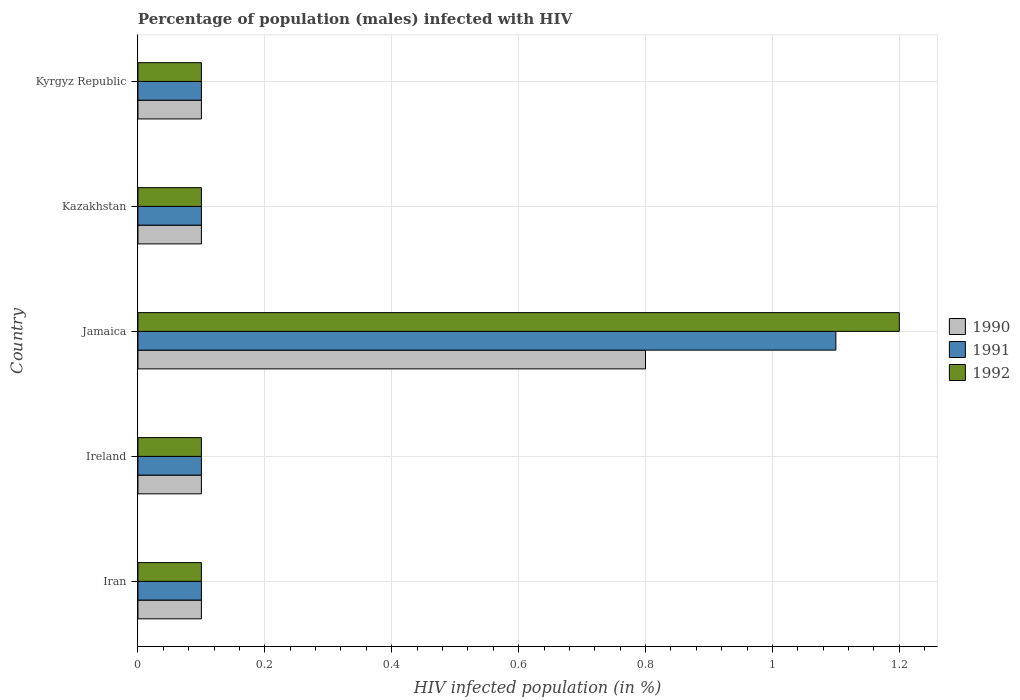How many groups of bars are there?
Your answer should be compact. 5. Are the number of bars per tick equal to the number of legend labels?
Keep it short and to the point. Yes. How many bars are there on the 5th tick from the top?
Offer a very short reply. 3. What is the label of the 4th group of bars from the top?
Offer a terse response. Ireland. What is the percentage of HIV infected male population in 1991 in Jamaica?
Provide a short and direct response. 1.1. Across all countries, what is the minimum percentage of HIV infected male population in 1992?
Offer a very short reply. 0.1. In which country was the percentage of HIV infected male population in 1990 maximum?
Your response must be concise. Jamaica. In which country was the percentage of HIV infected male population in 1992 minimum?
Give a very brief answer. Iran. What is the total percentage of HIV infected male population in 1990 in the graph?
Provide a succinct answer. 1.2. What is the difference between the percentage of HIV infected male population in 1992 in Iran and that in Jamaica?
Your answer should be compact. -1.1. What is the average percentage of HIV infected male population in 1990 per country?
Your answer should be very brief. 0.24. In how many countries, is the percentage of HIV infected male population in 1991 greater than 0.6400000000000001 %?
Offer a terse response. 1. What is the ratio of the percentage of HIV infected male population in 1990 in Jamaica to that in Kazakhstan?
Make the answer very short. 8. Is the percentage of HIV infected male population in 1991 in Jamaica less than that in Kyrgyz Republic?
Provide a short and direct response. No. What is the difference between the highest and the second highest percentage of HIV infected male population in 1990?
Your answer should be compact. 0.7. What is the difference between the highest and the lowest percentage of HIV infected male population in 1992?
Ensure brevity in your answer.  1.1. In how many countries, is the percentage of HIV infected male population in 1991 greater than the average percentage of HIV infected male population in 1991 taken over all countries?
Offer a very short reply. 1. Is the sum of the percentage of HIV infected male population in 1992 in Ireland and Kyrgyz Republic greater than the maximum percentage of HIV infected male population in 1991 across all countries?
Offer a very short reply. No. What does the 3rd bar from the top in Kazakhstan represents?
Provide a short and direct response. 1990. What does the 1st bar from the bottom in Kazakhstan represents?
Provide a short and direct response. 1990. How many bars are there?
Offer a terse response. 15. Does the graph contain any zero values?
Provide a succinct answer. No. Does the graph contain grids?
Make the answer very short. Yes. How many legend labels are there?
Ensure brevity in your answer.  3. How are the legend labels stacked?
Ensure brevity in your answer.  Vertical. What is the title of the graph?
Keep it short and to the point. Percentage of population (males) infected with HIV. What is the label or title of the X-axis?
Make the answer very short. HIV infected population (in %). What is the HIV infected population (in %) in 1990 in Iran?
Offer a terse response. 0.1. What is the HIV infected population (in %) in 1991 in Iran?
Give a very brief answer. 0.1. What is the HIV infected population (in %) in 1992 in Iran?
Keep it short and to the point. 0.1. What is the HIV infected population (in %) of 1991 in Ireland?
Provide a succinct answer. 0.1. What is the HIV infected population (in %) of 1992 in Ireland?
Keep it short and to the point. 0.1. What is the HIV infected population (in %) of 1990 in Jamaica?
Your answer should be compact. 0.8. What is the HIV infected population (in %) in 1991 in Jamaica?
Ensure brevity in your answer.  1.1. What is the HIV infected population (in %) in 1992 in Jamaica?
Your answer should be very brief. 1.2. What is the HIV infected population (in %) of 1990 in Kyrgyz Republic?
Your response must be concise. 0.1. What is the HIV infected population (in %) of 1991 in Kyrgyz Republic?
Give a very brief answer. 0.1. What is the HIV infected population (in %) of 1992 in Kyrgyz Republic?
Offer a terse response. 0.1. Across all countries, what is the maximum HIV infected population (in %) of 1991?
Your response must be concise. 1.1. Across all countries, what is the maximum HIV infected population (in %) in 1992?
Your answer should be very brief. 1.2. Across all countries, what is the minimum HIV infected population (in %) in 1992?
Keep it short and to the point. 0.1. What is the total HIV infected population (in %) in 1991 in the graph?
Provide a succinct answer. 1.5. What is the total HIV infected population (in %) in 1992 in the graph?
Offer a terse response. 1.6. What is the difference between the HIV infected population (in %) of 1990 in Iran and that in Ireland?
Your response must be concise. 0. What is the difference between the HIV infected population (in %) in 1991 in Iran and that in Ireland?
Keep it short and to the point. 0. What is the difference between the HIV infected population (in %) of 1992 in Iran and that in Ireland?
Your answer should be compact. 0. What is the difference between the HIV infected population (in %) in 1990 in Iran and that in Jamaica?
Your response must be concise. -0.7. What is the difference between the HIV infected population (in %) in 1991 in Iran and that in Jamaica?
Keep it short and to the point. -1. What is the difference between the HIV infected population (in %) in 1992 in Iran and that in Jamaica?
Offer a terse response. -1.1. What is the difference between the HIV infected population (in %) in 1991 in Iran and that in Kazakhstan?
Give a very brief answer. 0. What is the difference between the HIV infected population (in %) of 1992 in Iran and that in Kazakhstan?
Your response must be concise. 0. What is the difference between the HIV infected population (in %) in 1990 in Iran and that in Kyrgyz Republic?
Provide a succinct answer. 0. What is the difference between the HIV infected population (in %) in 1992 in Iran and that in Kyrgyz Republic?
Ensure brevity in your answer.  0. What is the difference between the HIV infected population (in %) of 1992 in Ireland and that in Jamaica?
Make the answer very short. -1.1. What is the difference between the HIV infected population (in %) in 1992 in Ireland and that in Kazakhstan?
Your response must be concise. 0. What is the difference between the HIV infected population (in %) of 1991 in Ireland and that in Kyrgyz Republic?
Ensure brevity in your answer.  0. What is the difference between the HIV infected population (in %) in 1991 in Jamaica and that in Kazakhstan?
Ensure brevity in your answer.  1. What is the difference between the HIV infected population (in %) in 1991 in Kazakhstan and that in Kyrgyz Republic?
Your response must be concise. 0. What is the difference between the HIV infected population (in %) of 1992 in Kazakhstan and that in Kyrgyz Republic?
Ensure brevity in your answer.  0. What is the difference between the HIV infected population (in %) of 1990 in Iran and the HIV infected population (in %) of 1992 in Ireland?
Provide a short and direct response. 0. What is the difference between the HIV infected population (in %) in 1991 in Iran and the HIV infected population (in %) in 1992 in Ireland?
Make the answer very short. 0. What is the difference between the HIV infected population (in %) in 1990 in Iran and the HIV infected population (in %) in 1992 in Jamaica?
Keep it short and to the point. -1.1. What is the difference between the HIV infected population (in %) of 1991 in Iran and the HIV infected population (in %) of 1992 in Kazakhstan?
Ensure brevity in your answer.  0. What is the difference between the HIV infected population (in %) in 1990 in Iran and the HIV infected population (in %) in 1992 in Kyrgyz Republic?
Your answer should be compact. 0. What is the difference between the HIV infected population (in %) in 1991 in Iran and the HIV infected population (in %) in 1992 in Kyrgyz Republic?
Your response must be concise. 0. What is the difference between the HIV infected population (in %) of 1990 in Ireland and the HIV infected population (in %) of 1991 in Jamaica?
Your answer should be very brief. -1. What is the difference between the HIV infected population (in %) in 1990 in Ireland and the HIV infected population (in %) in 1991 in Kyrgyz Republic?
Provide a succinct answer. 0. What is the difference between the HIV infected population (in %) in 1991 in Ireland and the HIV infected population (in %) in 1992 in Kyrgyz Republic?
Your answer should be very brief. 0. What is the difference between the HIV infected population (in %) of 1990 in Jamaica and the HIV infected population (in %) of 1991 in Kazakhstan?
Your answer should be very brief. 0.7. What is the difference between the HIV infected population (in %) of 1990 in Kazakhstan and the HIV infected population (in %) of 1991 in Kyrgyz Republic?
Your response must be concise. 0. What is the difference between the HIV infected population (in %) of 1991 in Kazakhstan and the HIV infected population (in %) of 1992 in Kyrgyz Republic?
Give a very brief answer. 0. What is the average HIV infected population (in %) in 1990 per country?
Provide a succinct answer. 0.24. What is the average HIV infected population (in %) of 1992 per country?
Keep it short and to the point. 0.32. What is the difference between the HIV infected population (in %) in 1990 and HIV infected population (in %) in 1991 in Iran?
Give a very brief answer. 0. What is the difference between the HIV infected population (in %) in 1990 and HIV infected population (in %) in 1992 in Iran?
Provide a short and direct response. 0. What is the difference between the HIV infected population (in %) in 1991 and HIV infected population (in %) in 1992 in Iran?
Your response must be concise. 0. What is the difference between the HIV infected population (in %) of 1990 and HIV infected population (in %) of 1992 in Ireland?
Make the answer very short. 0. What is the difference between the HIV infected population (in %) in 1990 and HIV infected population (in %) in 1992 in Jamaica?
Offer a very short reply. -0.4. What is the difference between the HIV infected population (in %) in 1991 and HIV infected population (in %) in 1992 in Kazakhstan?
Ensure brevity in your answer.  0. What is the difference between the HIV infected population (in %) of 1990 and HIV infected population (in %) of 1992 in Kyrgyz Republic?
Provide a succinct answer. 0. What is the difference between the HIV infected population (in %) of 1991 and HIV infected population (in %) of 1992 in Kyrgyz Republic?
Offer a very short reply. 0. What is the ratio of the HIV infected population (in %) in 1990 in Iran to that in Ireland?
Your response must be concise. 1. What is the ratio of the HIV infected population (in %) in 1991 in Iran to that in Jamaica?
Your answer should be compact. 0.09. What is the ratio of the HIV infected population (in %) of 1992 in Iran to that in Jamaica?
Offer a very short reply. 0.08. What is the ratio of the HIV infected population (in %) of 1990 in Iran to that in Kazakhstan?
Provide a succinct answer. 1. What is the ratio of the HIV infected population (in %) of 1990 in Ireland to that in Jamaica?
Your response must be concise. 0.12. What is the ratio of the HIV infected population (in %) of 1991 in Ireland to that in Jamaica?
Your answer should be compact. 0.09. What is the ratio of the HIV infected population (in %) in 1992 in Ireland to that in Jamaica?
Provide a short and direct response. 0.08. What is the ratio of the HIV infected population (in %) in 1992 in Ireland to that in Kyrgyz Republic?
Your answer should be very brief. 1. What is the ratio of the HIV infected population (in %) in 1990 in Jamaica to that in Kazakhstan?
Your answer should be very brief. 8. What is the ratio of the HIV infected population (in %) of 1992 in Jamaica to that in Kazakhstan?
Keep it short and to the point. 12. What is the ratio of the HIV infected population (in %) of 1990 in Jamaica to that in Kyrgyz Republic?
Keep it short and to the point. 8. What is the ratio of the HIV infected population (in %) in 1991 in Jamaica to that in Kyrgyz Republic?
Ensure brevity in your answer.  11. What is the ratio of the HIV infected population (in %) in 1992 in Jamaica to that in Kyrgyz Republic?
Offer a terse response. 12. What is the ratio of the HIV infected population (in %) of 1992 in Kazakhstan to that in Kyrgyz Republic?
Make the answer very short. 1. What is the difference between the highest and the second highest HIV infected population (in %) in 1990?
Make the answer very short. 0.7. What is the difference between the highest and the second highest HIV infected population (in %) in 1991?
Provide a succinct answer. 1. What is the difference between the highest and the lowest HIV infected population (in %) of 1990?
Keep it short and to the point. 0.7. What is the difference between the highest and the lowest HIV infected population (in %) in 1991?
Your answer should be compact. 1. What is the difference between the highest and the lowest HIV infected population (in %) in 1992?
Ensure brevity in your answer.  1.1. 